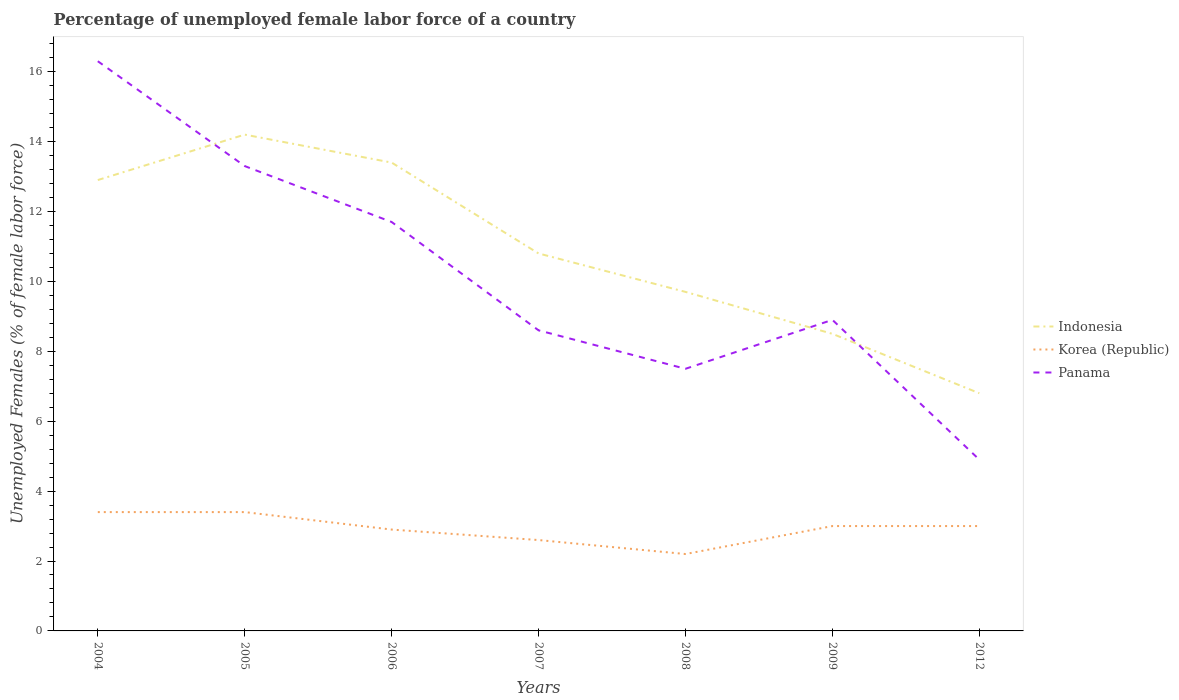Does the line corresponding to Korea (Republic) intersect with the line corresponding to Indonesia?
Offer a terse response. No. Is the number of lines equal to the number of legend labels?
Offer a terse response. Yes. Across all years, what is the maximum percentage of unemployed female labor force in Panama?
Your response must be concise. 4.9. In which year was the percentage of unemployed female labor force in Indonesia maximum?
Offer a very short reply. 2012. What is the total percentage of unemployed female labor force in Panama in the graph?
Keep it short and to the point. 3.7. What is the difference between the highest and the second highest percentage of unemployed female labor force in Indonesia?
Your answer should be very brief. 7.4. What is the difference between two consecutive major ticks on the Y-axis?
Make the answer very short. 2. Does the graph contain any zero values?
Your answer should be very brief. No. Where does the legend appear in the graph?
Keep it short and to the point. Center right. How many legend labels are there?
Make the answer very short. 3. What is the title of the graph?
Offer a very short reply. Percentage of unemployed female labor force of a country. What is the label or title of the Y-axis?
Provide a short and direct response. Unemployed Females (% of female labor force). What is the Unemployed Females (% of female labor force) of Indonesia in 2004?
Your answer should be compact. 12.9. What is the Unemployed Females (% of female labor force) in Korea (Republic) in 2004?
Provide a succinct answer. 3.4. What is the Unemployed Females (% of female labor force) in Panama in 2004?
Your response must be concise. 16.3. What is the Unemployed Females (% of female labor force) in Indonesia in 2005?
Give a very brief answer. 14.2. What is the Unemployed Females (% of female labor force) in Korea (Republic) in 2005?
Provide a short and direct response. 3.4. What is the Unemployed Females (% of female labor force) of Panama in 2005?
Make the answer very short. 13.3. What is the Unemployed Females (% of female labor force) in Indonesia in 2006?
Your response must be concise. 13.4. What is the Unemployed Females (% of female labor force) in Korea (Republic) in 2006?
Ensure brevity in your answer.  2.9. What is the Unemployed Females (% of female labor force) of Panama in 2006?
Provide a short and direct response. 11.7. What is the Unemployed Females (% of female labor force) in Indonesia in 2007?
Offer a very short reply. 10.8. What is the Unemployed Females (% of female labor force) in Korea (Republic) in 2007?
Provide a short and direct response. 2.6. What is the Unemployed Females (% of female labor force) in Panama in 2007?
Provide a succinct answer. 8.6. What is the Unemployed Females (% of female labor force) in Indonesia in 2008?
Your answer should be compact. 9.7. What is the Unemployed Females (% of female labor force) in Korea (Republic) in 2008?
Provide a short and direct response. 2.2. What is the Unemployed Females (% of female labor force) of Korea (Republic) in 2009?
Give a very brief answer. 3. What is the Unemployed Females (% of female labor force) in Panama in 2009?
Ensure brevity in your answer.  8.9. What is the Unemployed Females (% of female labor force) of Indonesia in 2012?
Provide a short and direct response. 6.8. What is the Unemployed Females (% of female labor force) of Panama in 2012?
Provide a succinct answer. 4.9. Across all years, what is the maximum Unemployed Females (% of female labor force) in Indonesia?
Offer a terse response. 14.2. Across all years, what is the maximum Unemployed Females (% of female labor force) in Korea (Republic)?
Your answer should be compact. 3.4. Across all years, what is the maximum Unemployed Females (% of female labor force) in Panama?
Give a very brief answer. 16.3. Across all years, what is the minimum Unemployed Females (% of female labor force) of Indonesia?
Your response must be concise. 6.8. Across all years, what is the minimum Unemployed Females (% of female labor force) of Korea (Republic)?
Your response must be concise. 2.2. Across all years, what is the minimum Unemployed Females (% of female labor force) in Panama?
Make the answer very short. 4.9. What is the total Unemployed Females (% of female labor force) in Indonesia in the graph?
Keep it short and to the point. 76.3. What is the total Unemployed Females (% of female labor force) in Panama in the graph?
Give a very brief answer. 71.2. What is the difference between the Unemployed Females (% of female labor force) in Korea (Republic) in 2004 and that in 2005?
Keep it short and to the point. 0. What is the difference between the Unemployed Females (% of female labor force) of Indonesia in 2004 and that in 2006?
Make the answer very short. -0.5. What is the difference between the Unemployed Females (% of female labor force) of Korea (Republic) in 2004 and that in 2006?
Give a very brief answer. 0.5. What is the difference between the Unemployed Females (% of female labor force) of Panama in 2004 and that in 2006?
Your response must be concise. 4.6. What is the difference between the Unemployed Females (% of female labor force) of Indonesia in 2004 and that in 2007?
Your answer should be very brief. 2.1. What is the difference between the Unemployed Females (% of female labor force) in Korea (Republic) in 2004 and that in 2007?
Your response must be concise. 0.8. What is the difference between the Unemployed Females (% of female labor force) of Indonesia in 2004 and that in 2008?
Your answer should be very brief. 3.2. What is the difference between the Unemployed Females (% of female labor force) in Indonesia in 2004 and that in 2009?
Offer a very short reply. 4.4. What is the difference between the Unemployed Females (% of female labor force) in Indonesia in 2004 and that in 2012?
Ensure brevity in your answer.  6.1. What is the difference between the Unemployed Females (% of female labor force) of Panama in 2004 and that in 2012?
Make the answer very short. 11.4. What is the difference between the Unemployed Females (% of female labor force) in Indonesia in 2005 and that in 2006?
Your answer should be compact. 0.8. What is the difference between the Unemployed Females (% of female labor force) in Korea (Republic) in 2005 and that in 2006?
Offer a terse response. 0.5. What is the difference between the Unemployed Females (% of female labor force) in Panama in 2005 and that in 2006?
Your answer should be compact. 1.6. What is the difference between the Unemployed Females (% of female labor force) of Korea (Republic) in 2005 and that in 2007?
Make the answer very short. 0.8. What is the difference between the Unemployed Females (% of female labor force) of Panama in 2005 and that in 2007?
Provide a succinct answer. 4.7. What is the difference between the Unemployed Females (% of female labor force) in Indonesia in 2005 and that in 2008?
Ensure brevity in your answer.  4.5. What is the difference between the Unemployed Females (% of female labor force) of Indonesia in 2005 and that in 2009?
Provide a short and direct response. 5.7. What is the difference between the Unemployed Females (% of female labor force) of Korea (Republic) in 2005 and that in 2009?
Offer a very short reply. 0.4. What is the difference between the Unemployed Females (% of female labor force) of Indonesia in 2005 and that in 2012?
Offer a very short reply. 7.4. What is the difference between the Unemployed Females (% of female labor force) of Korea (Republic) in 2005 and that in 2012?
Offer a terse response. 0.4. What is the difference between the Unemployed Females (% of female labor force) of Panama in 2005 and that in 2012?
Ensure brevity in your answer.  8.4. What is the difference between the Unemployed Females (% of female labor force) of Indonesia in 2006 and that in 2008?
Your response must be concise. 3.7. What is the difference between the Unemployed Females (% of female labor force) of Korea (Republic) in 2006 and that in 2008?
Offer a very short reply. 0.7. What is the difference between the Unemployed Females (% of female labor force) of Panama in 2006 and that in 2008?
Offer a terse response. 4.2. What is the difference between the Unemployed Females (% of female labor force) of Indonesia in 2006 and that in 2009?
Provide a succinct answer. 4.9. What is the difference between the Unemployed Females (% of female labor force) in Panama in 2006 and that in 2009?
Provide a short and direct response. 2.8. What is the difference between the Unemployed Females (% of female labor force) of Indonesia in 2006 and that in 2012?
Your response must be concise. 6.6. What is the difference between the Unemployed Females (% of female labor force) in Korea (Republic) in 2006 and that in 2012?
Provide a short and direct response. -0.1. What is the difference between the Unemployed Females (% of female labor force) in Indonesia in 2007 and that in 2008?
Ensure brevity in your answer.  1.1. What is the difference between the Unemployed Females (% of female labor force) of Panama in 2007 and that in 2008?
Ensure brevity in your answer.  1.1. What is the difference between the Unemployed Females (% of female labor force) of Indonesia in 2007 and that in 2009?
Your response must be concise. 2.3. What is the difference between the Unemployed Females (% of female labor force) of Panama in 2007 and that in 2009?
Offer a very short reply. -0.3. What is the difference between the Unemployed Females (% of female labor force) in Indonesia in 2007 and that in 2012?
Give a very brief answer. 4. What is the difference between the Unemployed Females (% of female labor force) in Korea (Republic) in 2007 and that in 2012?
Offer a terse response. -0.4. What is the difference between the Unemployed Females (% of female labor force) in Panama in 2007 and that in 2012?
Provide a short and direct response. 3.7. What is the difference between the Unemployed Females (% of female labor force) in Indonesia in 2008 and that in 2009?
Offer a very short reply. 1.2. What is the difference between the Unemployed Females (% of female labor force) in Korea (Republic) in 2008 and that in 2009?
Ensure brevity in your answer.  -0.8. What is the difference between the Unemployed Females (% of female labor force) of Panama in 2008 and that in 2009?
Provide a succinct answer. -1.4. What is the difference between the Unemployed Females (% of female labor force) in Indonesia in 2008 and that in 2012?
Provide a succinct answer. 2.9. What is the difference between the Unemployed Females (% of female labor force) in Korea (Republic) in 2008 and that in 2012?
Provide a short and direct response. -0.8. What is the difference between the Unemployed Females (% of female labor force) in Panama in 2008 and that in 2012?
Your answer should be very brief. 2.6. What is the difference between the Unemployed Females (% of female labor force) of Korea (Republic) in 2009 and that in 2012?
Your response must be concise. 0. What is the difference between the Unemployed Females (% of female labor force) of Indonesia in 2004 and the Unemployed Females (% of female labor force) of Korea (Republic) in 2005?
Ensure brevity in your answer.  9.5. What is the difference between the Unemployed Females (% of female labor force) of Indonesia in 2004 and the Unemployed Females (% of female labor force) of Panama in 2005?
Your answer should be very brief. -0.4. What is the difference between the Unemployed Females (% of female labor force) of Indonesia in 2004 and the Unemployed Females (% of female labor force) of Korea (Republic) in 2006?
Keep it short and to the point. 10. What is the difference between the Unemployed Females (% of female labor force) in Indonesia in 2004 and the Unemployed Females (% of female labor force) in Panama in 2006?
Ensure brevity in your answer.  1.2. What is the difference between the Unemployed Females (% of female labor force) in Korea (Republic) in 2004 and the Unemployed Females (% of female labor force) in Panama in 2006?
Keep it short and to the point. -8.3. What is the difference between the Unemployed Females (% of female labor force) of Indonesia in 2004 and the Unemployed Females (% of female labor force) of Korea (Republic) in 2007?
Keep it short and to the point. 10.3. What is the difference between the Unemployed Females (% of female labor force) of Indonesia in 2004 and the Unemployed Females (% of female labor force) of Panama in 2007?
Make the answer very short. 4.3. What is the difference between the Unemployed Females (% of female labor force) in Korea (Republic) in 2004 and the Unemployed Females (% of female labor force) in Panama in 2009?
Provide a succinct answer. -5.5. What is the difference between the Unemployed Females (% of female labor force) of Indonesia in 2004 and the Unemployed Females (% of female labor force) of Korea (Republic) in 2012?
Provide a succinct answer. 9.9. What is the difference between the Unemployed Females (% of female labor force) of Korea (Republic) in 2004 and the Unemployed Females (% of female labor force) of Panama in 2012?
Give a very brief answer. -1.5. What is the difference between the Unemployed Females (% of female labor force) in Korea (Republic) in 2005 and the Unemployed Females (% of female labor force) in Panama in 2007?
Your answer should be very brief. -5.2. What is the difference between the Unemployed Females (% of female labor force) of Indonesia in 2005 and the Unemployed Females (% of female labor force) of Korea (Republic) in 2008?
Give a very brief answer. 12. What is the difference between the Unemployed Females (% of female labor force) of Korea (Republic) in 2005 and the Unemployed Females (% of female labor force) of Panama in 2008?
Offer a terse response. -4.1. What is the difference between the Unemployed Females (% of female labor force) in Indonesia in 2005 and the Unemployed Females (% of female labor force) in Panama in 2009?
Keep it short and to the point. 5.3. What is the difference between the Unemployed Females (% of female labor force) of Indonesia in 2005 and the Unemployed Females (% of female labor force) of Korea (Republic) in 2012?
Your answer should be very brief. 11.2. What is the difference between the Unemployed Females (% of female labor force) of Indonesia in 2005 and the Unemployed Females (% of female labor force) of Panama in 2012?
Provide a short and direct response. 9.3. What is the difference between the Unemployed Females (% of female labor force) of Korea (Republic) in 2005 and the Unemployed Females (% of female labor force) of Panama in 2012?
Offer a terse response. -1.5. What is the difference between the Unemployed Females (% of female labor force) of Indonesia in 2006 and the Unemployed Females (% of female labor force) of Panama in 2007?
Offer a terse response. 4.8. What is the difference between the Unemployed Females (% of female labor force) in Korea (Republic) in 2006 and the Unemployed Females (% of female labor force) in Panama in 2007?
Give a very brief answer. -5.7. What is the difference between the Unemployed Females (% of female labor force) in Indonesia in 2006 and the Unemployed Females (% of female labor force) in Panama in 2008?
Ensure brevity in your answer.  5.9. What is the difference between the Unemployed Females (% of female labor force) of Indonesia in 2006 and the Unemployed Females (% of female labor force) of Panama in 2009?
Your response must be concise. 4.5. What is the difference between the Unemployed Females (% of female labor force) of Indonesia in 2007 and the Unemployed Females (% of female labor force) of Panama in 2008?
Provide a short and direct response. 3.3. What is the difference between the Unemployed Females (% of female labor force) in Korea (Republic) in 2007 and the Unemployed Females (% of female labor force) in Panama in 2008?
Give a very brief answer. -4.9. What is the difference between the Unemployed Females (% of female labor force) of Indonesia in 2007 and the Unemployed Females (% of female labor force) of Panama in 2009?
Make the answer very short. 1.9. What is the difference between the Unemployed Females (% of female labor force) of Indonesia in 2007 and the Unemployed Females (% of female labor force) of Panama in 2012?
Your answer should be very brief. 5.9. What is the difference between the Unemployed Females (% of female labor force) of Korea (Republic) in 2007 and the Unemployed Females (% of female labor force) of Panama in 2012?
Offer a very short reply. -2.3. What is the difference between the Unemployed Females (% of female labor force) of Indonesia in 2008 and the Unemployed Females (% of female labor force) of Panama in 2009?
Provide a succinct answer. 0.8. What is the difference between the Unemployed Females (% of female labor force) of Korea (Republic) in 2008 and the Unemployed Females (% of female labor force) of Panama in 2009?
Offer a very short reply. -6.7. What is the difference between the Unemployed Females (% of female labor force) of Indonesia in 2008 and the Unemployed Females (% of female labor force) of Korea (Republic) in 2012?
Offer a terse response. 6.7. What is the difference between the Unemployed Females (% of female labor force) of Korea (Republic) in 2008 and the Unemployed Females (% of female labor force) of Panama in 2012?
Your answer should be compact. -2.7. What is the difference between the Unemployed Females (% of female labor force) of Indonesia in 2009 and the Unemployed Females (% of female labor force) of Panama in 2012?
Provide a succinct answer. 3.6. What is the difference between the Unemployed Females (% of female labor force) in Korea (Republic) in 2009 and the Unemployed Females (% of female labor force) in Panama in 2012?
Offer a very short reply. -1.9. What is the average Unemployed Females (% of female labor force) in Korea (Republic) per year?
Provide a short and direct response. 2.93. What is the average Unemployed Females (% of female labor force) of Panama per year?
Your answer should be compact. 10.17. In the year 2005, what is the difference between the Unemployed Females (% of female labor force) in Indonesia and Unemployed Females (% of female labor force) in Panama?
Ensure brevity in your answer.  0.9. In the year 2006, what is the difference between the Unemployed Females (% of female labor force) of Indonesia and Unemployed Females (% of female labor force) of Korea (Republic)?
Provide a short and direct response. 10.5. In the year 2006, what is the difference between the Unemployed Females (% of female labor force) in Indonesia and Unemployed Females (% of female labor force) in Panama?
Make the answer very short. 1.7. In the year 2007, what is the difference between the Unemployed Females (% of female labor force) of Indonesia and Unemployed Females (% of female labor force) of Korea (Republic)?
Ensure brevity in your answer.  8.2. In the year 2007, what is the difference between the Unemployed Females (% of female labor force) in Korea (Republic) and Unemployed Females (% of female labor force) in Panama?
Provide a short and direct response. -6. In the year 2008, what is the difference between the Unemployed Females (% of female labor force) in Indonesia and Unemployed Females (% of female labor force) in Korea (Republic)?
Provide a short and direct response. 7.5. In the year 2008, what is the difference between the Unemployed Females (% of female labor force) in Korea (Republic) and Unemployed Females (% of female labor force) in Panama?
Offer a very short reply. -5.3. In the year 2009, what is the difference between the Unemployed Females (% of female labor force) of Indonesia and Unemployed Females (% of female labor force) of Panama?
Your answer should be compact. -0.4. In the year 2009, what is the difference between the Unemployed Females (% of female labor force) of Korea (Republic) and Unemployed Females (% of female labor force) of Panama?
Keep it short and to the point. -5.9. In the year 2012, what is the difference between the Unemployed Females (% of female labor force) of Indonesia and Unemployed Females (% of female labor force) of Korea (Republic)?
Your answer should be compact. 3.8. In the year 2012, what is the difference between the Unemployed Females (% of female labor force) of Indonesia and Unemployed Females (% of female labor force) of Panama?
Provide a short and direct response. 1.9. What is the ratio of the Unemployed Females (% of female labor force) of Indonesia in 2004 to that in 2005?
Your answer should be very brief. 0.91. What is the ratio of the Unemployed Females (% of female labor force) in Panama in 2004 to that in 2005?
Keep it short and to the point. 1.23. What is the ratio of the Unemployed Females (% of female labor force) of Indonesia in 2004 to that in 2006?
Offer a very short reply. 0.96. What is the ratio of the Unemployed Females (% of female labor force) of Korea (Republic) in 2004 to that in 2006?
Provide a succinct answer. 1.17. What is the ratio of the Unemployed Females (% of female labor force) of Panama in 2004 to that in 2006?
Your response must be concise. 1.39. What is the ratio of the Unemployed Females (% of female labor force) in Indonesia in 2004 to that in 2007?
Offer a terse response. 1.19. What is the ratio of the Unemployed Females (% of female labor force) in Korea (Republic) in 2004 to that in 2007?
Provide a succinct answer. 1.31. What is the ratio of the Unemployed Females (% of female labor force) in Panama in 2004 to that in 2007?
Ensure brevity in your answer.  1.9. What is the ratio of the Unemployed Females (% of female labor force) in Indonesia in 2004 to that in 2008?
Make the answer very short. 1.33. What is the ratio of the Unemployed Females (% of female labor force) of Korea (Republic) in 2004 to that in 2008?
Provide a succinct answer. 1.55. What is the ratio of the Unemployed Females (% of female labor force) of Panama in 2004 to that in 2008?
Make the answer very short. 2.17. What is the ratio of the Unemployed Females (% of female labor force) of Indonesia in 2004 to that in 2009?
Give a very brief answer. 1.52. What is the ratio of the Unemployed Females (% of female labor force) of Korea (Republic) in 2004 to that in 2009?
Give a very brief answer. 1.13. What is the ratio of the Unemployed Females (% of female labor force) of Panama in 2004 to that in 2009?
Offer a terse response. 1.83. What is the ratio of the Unemployed Females (% of female labor force) in Indonesia in 2004 to that in 2012?
Your answer should be compact. 1.9. What is the ratio of the Unemployed Females (% of female labor force) in Korea (Republic) in 2004 to that in 2012?
Ensure brevity in your answer.  1.13. What is the ratio of the Unemployed Females (% of female labor force) in Panama in 2004 to that in 2012?
Ensure brevity in your answer.  3.33. What is the ratio of the Unemployed Females (% of female labor force) of Indonesia in 2005 to that in 2006?
Your answer should be compact. 1.06. What is the ratio of the Unemployed Females (% of female labor force) in Korea (Republic) in 2005 to that in 2006?
Offer a very short reply. 1.17. What is the ratio of the Unemployed Females (% of female labor force) in Panama in 2005 to that in 2006?
Provide a short and direct response. 1.14. What is the ratio of the Unemployed Females (% of female labor force) of Indonesia in 2005 to that in 2007?
Keep it short and to the point. 1.31. What is the ratio of the Unemployed Females (% of female labor force) of Korea (Republic) in 2005 to that in 2007?
Ensure brevity in your answer.  1.31. What is the ratio of the Unemployed Females (% of female labor force) of Panama in 2005 to that in 2007?
Offer a very short reply. 1.55. What is the ratio of the Unemployed Females (% of female labor force) of Indonesia in 2005 to that in 2008?
Provide a succinct answer. 1.46. What is the ratio of the Unemployed Females (% of female labor force) in Korea (Republic) in 2005 to that in 2008?
Make the answer very short. 1.55. What is the ratio of the Unemployed Females (% of female labor force) of Panama in 2005 to that in 2008?
Ensure brevity in your answer.  1.77. What is the ratio of the Unemployed Females (% of female labor force) in Indonesia in 2005 to that in 2009?
Keep it short and to the point. 1.67. What is the ratio of the Unemployed Females (% of female labor force) of Korea (Republic) in 2005 to that in 2009?
Keep it short and to the point. 1.13. What is the ratio of the Unemployed Females (% of female labor force) in Panama in 2005 to that in 2009?
Keep it short and to the point. 1.49. What is the ratio of the Unemployed Females (% of female labor force) in Indonesia in 2005 to that in 2012?
Ensure brevity in your answer.  2.09. What is the ratio of the Unemployed Females (% of female labor force) of Korea (Republic) in 2005 to that in 2012?
Make the answer very short. 1.13. What is the ratio of the Unemployed Females (% of female labor force) of Panama in 2005 to that in 2012?
Make the answer very short. 2.71. What is the ratio of the Unemployed Females (% of female labor force) of Indonesia in 2006 to that in 2007?
Make the answer very short. 1.24. What is the ratio of the Unemployed Females (% of female labor force) in Korea (Republic) in 2006 to that in 2007?
Provide a short and direct response. 1.12. What is the ratio of the Unemployed Females (% of female labor force) of Panama in 2006 to that in 2007?
Ensure brevity in your answer.  1.36. What is the ratio of the Unemployed Females (% of female labor force) of Indonesia in 2006 to that in 2008?
Your answer should be compact. 1.38. What is the ratio of the Unemployed Females (% of female labor force) of Korea (Republic) in 2006 to that in 2008?
Your answer should be very brief. 1.32. What is the ratio of the Unemployed Females (% of female labor force) in Panama in 2006 to that in 2008?
Your answer should be compact. 1.56. What is the ratio of the Unemployed Females (% of female labor force) in Indonesia in 2006 to that in 2009?
Ensure brevity in your answer.  1.58. What is the ratio of the Unemployed Females (% of female labor force) of Korea (Republic) in 2006 to that in 2009?
Make the answer very short. 0.97. What is the ratio of the Unemployed Females (% of female labor force) in Panama in 2006 to that in 2009?
Make the answer very short. 1.31. What is the ratio of the Unemployed Females (% of female labor force) in Indonesia in 2006 to that in 2012?
Offer a very short reply. 1.97. What is the ratio of the Unemployed Females (% of female labor force) of Korea (Republic) in 2006 to that in 2012?
Keep it short and to the point. 0.97. What is the ratio of the Unemployed Females (% of female labor force) of Panama in 2006 to that in 2012?
Ensure brevity in your answer.  2.39. What is the ratio of the Unemployed Females (% of female labor force) of Indonesia in 2007 to that in 2008?
Your response must be concise. 1.11. What is the ratio of the Unemployed Females (% of female labor force) in Korea (Republic) in 2007 to that in 2008?
Keep it short and to the point. 1.18. What is the ratio of the Unemployed Females (% of female labor force) in Panama in 2007 to that in 2008?
Provide a short and direct response. 1.15. What is the ratio of the Unemployed Females (% of female labor force) in Indonesia in 2007 to that in 2009?
Your answer should be compact. 1.27. What is the ratio of the Unemployed Females (% of female labor force) in Korea (Republic) in 2007 to that in 2009?
Your response must be concise. 0.87. What is the ratio of the Unemployed Females (% of female labor force) of Panama in 2007 to that in 2009?
Offer a terse response. 0.97. What is the ratio of the Unemployed Females (% of female labor force) of Indonesia in 2007 to that in 2012?
Provide a short and direct response. 1.59. What is the ratio of the Unemployed Females (% of female labor force) in Korea (Republic) in 2007 to that in 2012?
Ensure brevity in your answer.  0.87. What is the ratio of the Unemployed Females (% of female labor force) of Panama in 2007 to that in 2012?
Your answer should be compact. 1.76. What is the ratio of the Unemployed Females (% of female labor force) of Indonesia in 2008 to that in 2009?
Your answer should be very brief. 1.14. What is the ratio of the Unemployed Females (% of female labor force) of Korea (Republic) in 2008 to that in 2009?
Provide a succinct answer. 0.73. What is the ratio of the Unemployed Females (% of female labor force) of Panama in 2008 to that in 2009?
Ensure brevity in your answer.  0.84. What is the ratio of the Unemployed Females (% of female labor force) of Indonesia in 2008 to that in 2012?
Offer a terse response. 1.43. What is the ratio of the Unemployed Females (% of female labor force) in Korea (Republic) in 2008 to that in 2012?
Your response must be concise. 0.73. What is the ratio of the Unemployed Females (% of female labor force) in Panama in 2008 to that in 2012?
Your response must be concise. 1.53. What is the ratio of the Unemployed Females (% of female labor force) of Indonesia in 2009 to that in 2012?
Your answer should be compact. 1.25. What is the ratio of the Unemployed Females (% of female labor force) of Panama in 2009 to that in 2012?
Give a very brief answer. 1.82. What is the difference between the highest and the second highest Unemployed Females (% of female labor force) in Korea (Republic)?
Offer a terse response. 0. What is the difference between the highest and the lowest Unemployed Females (% of female labor force) of Korea (Republic)?
Your answer should be compact. 1.2. What is the difference between the highest and the lowest Unemployed Females (% of female labor force) in Panama?
Offer a terse response. 11.4. 